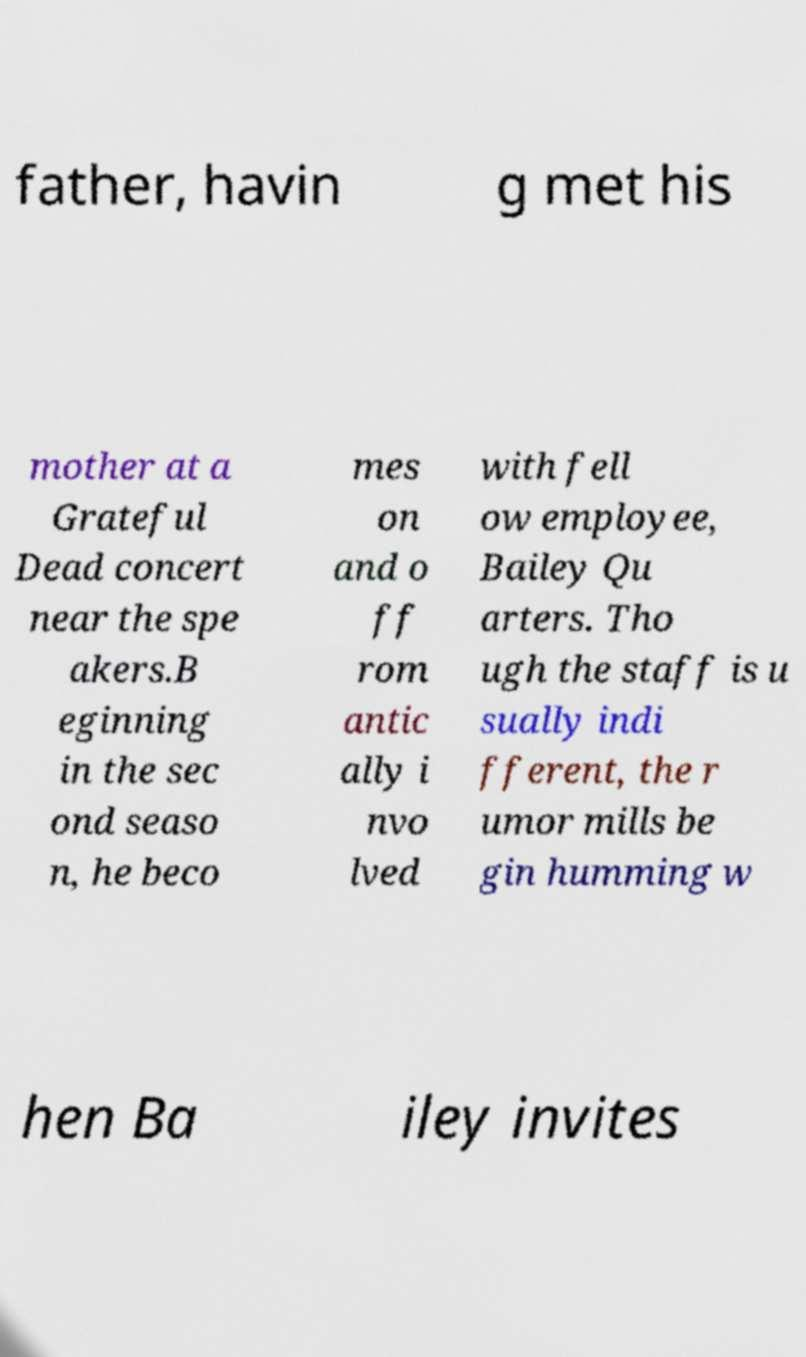I need the written content from this picture converted into text. Can you do that? father, havin g met his mother at a Grateful Dead concert near the spe akers.B eginning in the sec ond seaso n, he beco mes on and o ff rom antic ally i nvo lved with fell ow employee, Bailey Qu arters. Tho ugh the staff is u sually indi fferent, the r umor mills be gin humming w hen Ba iley invites 